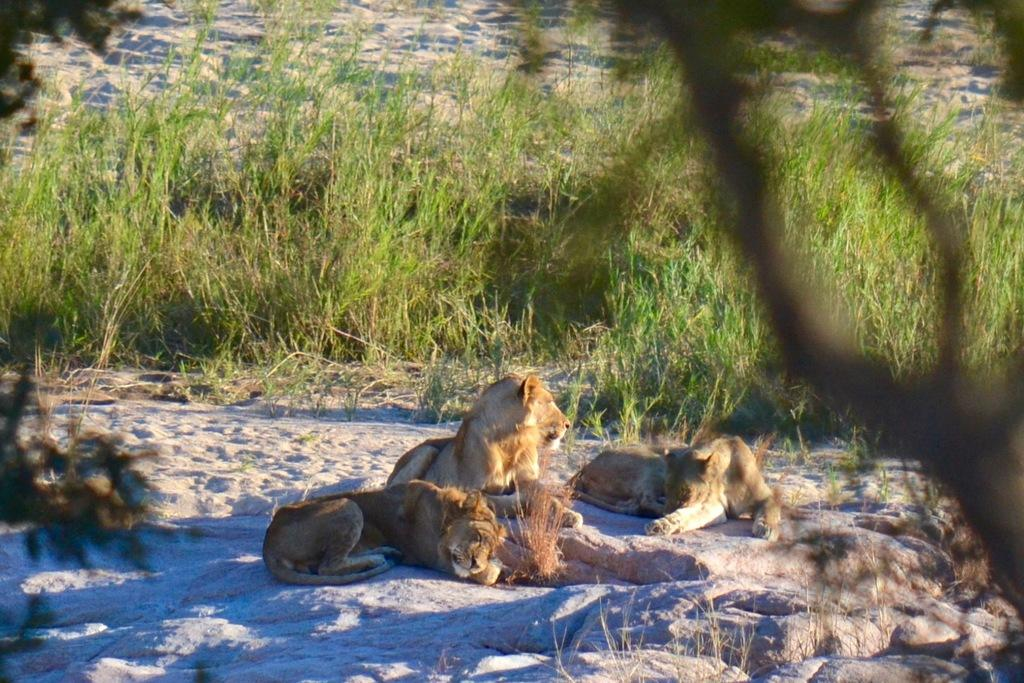What types of living organisms can be seen in the image? There are animals in the image. What type of terrain is visible in the image? There is grass and sand visible in the image. What type of shade does the writer use in the image? There is no writer or shade present in the image. 